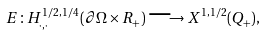<formula> <loc_0><loc_0><loc_500><loc_500>E \colon H _ { \cdot , \cdot } ^ { 1 / 2 , 1 / 4 } ( \partial \Omega \times { R } _ { + } ) \longrightarrow X ^ { 1 , 1 / 2 } ( Q _ { + } ) ,</formula> 